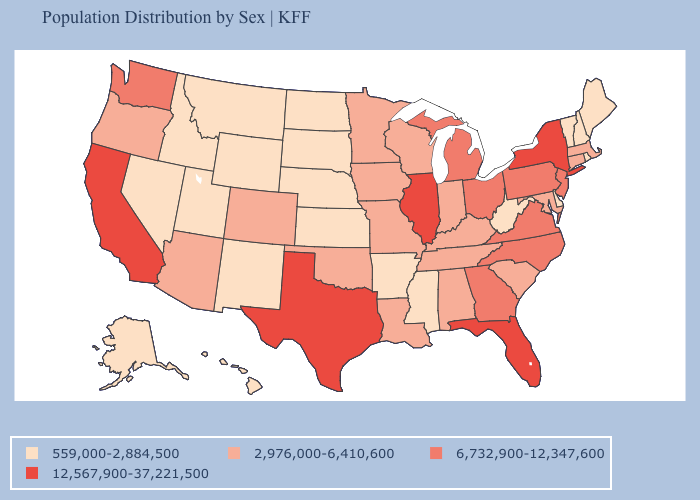What is the lowest value in states that border Mississippi?
Write a very short answer. 559,000-2,884,500. Does Arkansas have a lower value than South Carolina?
Concise answer only. Yes. What is the value of South Dakota?
Short answer required. 559,000-2,884,500. What is the value of Nebraska?
Short answer required. 559,000-2,884,500. What is the value of West Virginia?
Give a very brief answer. 559,000-2,884,500. What is the highest value in the Northeast ?
Short answer required. 12,567,900-37,221,500. Name the states that have a value in the range 6,732,900-12,347,600?
Be succinct. Georgia, Michigan, New Jersey, North Carolina, Ohio, Pennsylvania, Virginia, Washington. What is the value of Florida?
Be succinct. 12,567,900-37,221,500. Which states have the lowest value in the USA?
Be succinct. Alaska, Arkansas, Delaware, Hawaii, Idaho, Kansas, Maine, Mississippi, Montana, Nebraska, Nevada, New Hampshire, New Mexico, North Dakota, Rhode Island, South Dakota, Utah, Vermont, West Virginia, Wyoming. What is the value of Hawaii?
Short answer required. 559,000-2,884,500. What is the value of Indiana?
Keep it brief. 2,976,000-6,410,600. What is the highest value in the South ?
Give a very brief answer. 12,567,900-37,221,500. Does Delaware have the same value as Nebraska?
Keep it brief. Yes. What is the highest value in states that border Texas?
Answer briefly. 2,976,000-6,410,600. Among the states that border Connecticut , does New York have the lowest value?
Short answer required. No. 